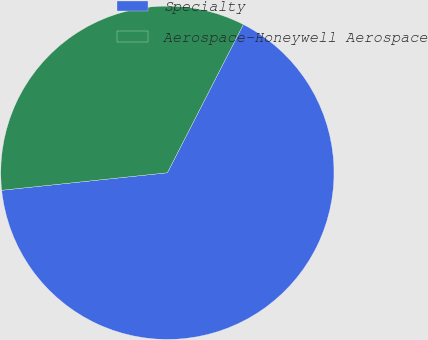Convert chart. <chart><loc_0><loc_0><loc_500><loc_500><pie_chart><fcel>Specialty<fcel>Aerospace-Honeywell Aerospace<nl><fcel>65.79%<fcel>34.21%<nl></chart> 